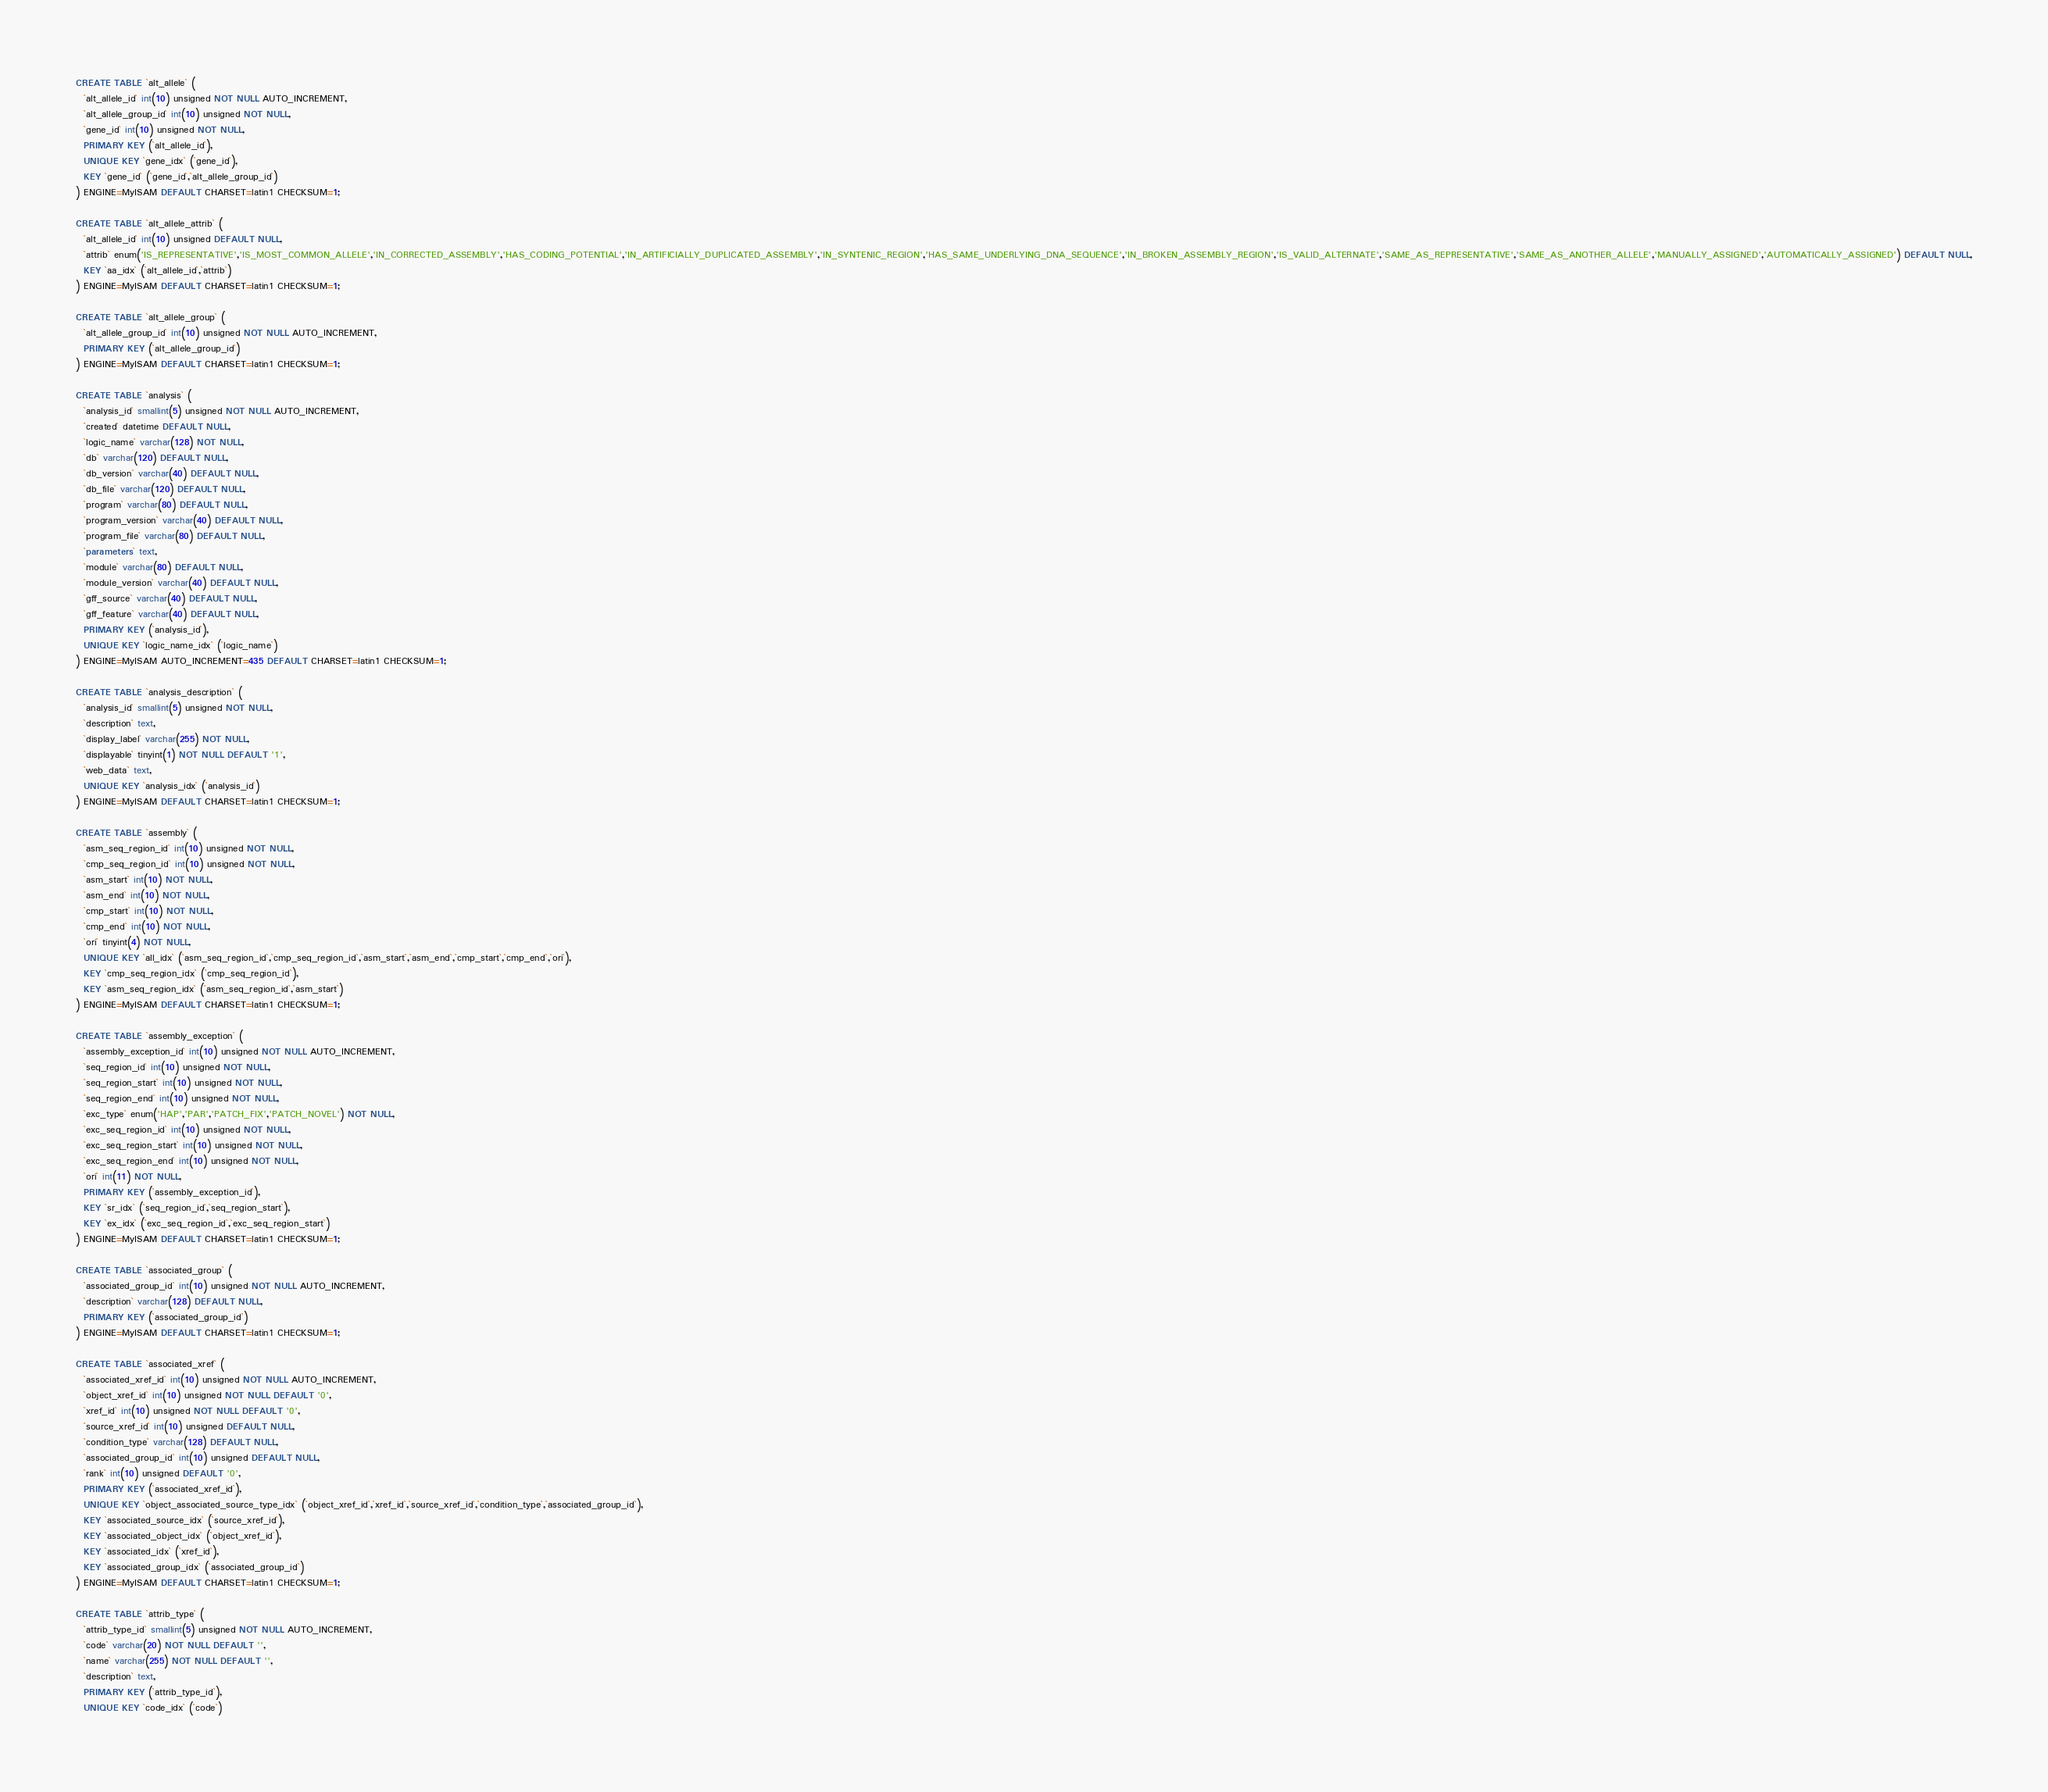<code> <loc_0><loc_0><loc_500><loc_500><_SQL_>CREATE TABLE `alt_allele` (
  `alt_allele_id` int(10) unsigned NOT NULL AUTO_INCREMENT,
  `alt_allele_group_id` int(10) unsigned NOT NULL,
  `gene_id` int(10) unsigned NOT NULL,
  PRIMARY KEY (`alt_allele_id`),
  UNIQUE KEY `gene_idx` (`gene_id`),
  KEY `gene_id` (`gene_id`,`alt_allele_group_id`)
) ENGINE=MyISAM DEFAULT CHARSET=latin1 CHECKSUM=1;

CREATE TABLE `alt_allele_attrib` (
  `alt_allele_id` int(10) unsigned DEFAULT NULL,
  `attrib` enum('IS_REPRESENTATIVE','IS_MOST_COMMON_ALLELE','IN_CORRECTED_ASSEMBLY','HAS_CODING_POTENTIAL','IN_ARTIFICIALLY_DUPLICATED_ASSEMBLY','IN_SYNTENIC_REGION','HAS_SAME_UNDERLYING_DNA_SEQUENCE','IN_BROKEN_ASSEMBLY_REGION','IS_VALID_ALTERNATE','SAME_AS_REPRESENTATIVE','SAME_AS_ANOTHER_ALLELE','MANUALLY_ASSIGNED','AUTOMATICALLY_ASSIGNED') DEFAULT NULL,
  KEY `aa_idx` (`alt_allele_id`,`attrib`)
) ENGINE=MyISAM DEFAULT CHARSET=latin1 CHECKSUM=1;

CREATE TABLE `alt_allele_group` (
  `alt_allele_group_id` int(10) unsigned NOT NULL AUTO_INCREMENT,
  PRIMARY KEY (`alt_allele_group_id`)
) ENGINE=MyISAM DEFAULT CHARSET=latin1 CHECKSUM=1;

CREATE TABLE `analysis` (
  `analysis_id` smallint(5) unsigned NOT NULL AUTO_INCREMENT,
  `created` datetime DEFAULT NULL,
  `logic_name` varchar(128) NOT NULL,
  `db` varchar(120) DEFAULT NULL,
  `db_version` varchar(40) DEFAULT NULL,
  `db_file` varchar(120) DEFAULT NULL,
  `program` varchar(80) DEFAULT NULL,
  `program_version` varchar(40) DEFAULT NULL,
  `program_file` varchar(80) DEFAULT NULL,
  `parameters` text,
  `module` varchar(80) DEFAULT NULL,
  `module_version` varchar(40) DEFAULT NULL,
  `gff_source` varchar(40) DEFAULT NULL,
  `gff_feature` varchar(40) DEFAULT NULL,
  PRIMARY KEY (`analysis_id`),
  UNIQUE KEY `logic_name_idx` (`logic_name`)
) ENGINE=MyISAM AUTO_INCREMENT=435 DEFAULT CHARSET=latin1 CHECKSUM=1;

CREATE TABLE `analysis_description` (
  `analysis_id` smallint(5) unsigned NOT NULL,
  `description` text,
  `display_label` varchar(255) NOT NULL,
  `displayable` tinyint(1) NOT NULL DEFAULT '1',
  `web_data` text,
  UNIQUE KEY `analysis_idx` (`analysis_id`)
) ENGINE=MyISAM DEFAULT CHARSET=latin1 CHECKSUM=1;

CREATE TABLE `assembly` (
  `asm_seq_region_id` int(10) unsigned NOT NULL,
  `cmp_seq_region_id` int(10) unsigned NOT NULL,
  `asm_start` int(10) NOT NULL,
  `asm_end` int(10) NOT NULL,
  `cmp_start` int(10) NOT NULL,
  `cmp_end` int(10) NOT NULL,
  `ori` tinyint(4) NOT NULL,
  UNIQUE KEY `all_idx` (`asm_seq_region_id`,`cmp_seq_region_id`,`asm_start`,`asm_end`,`cmp_start`,`cmp_end`,`ori`),
  KEY `cmp_seq_region_idx` (`cmp_seq_region_id`),
  KEY `asm_seq_region_idx` (`asm_seq_region_id`,`asm_start`)
) ENGINE=MyISAM DEFAULT CHARSET=latin1 CHECKSUM=1;

CREATE TABLE `assembly_exception` (
  `assembly_exception_id` int(10) unsigned NOT NULL AUTO_INCREMENT,
  `seq_region_id` int(10) unsigned NOT NULL,
  `seq_region_start` int(10) unsigned NOT NULL,
  `seq_region_end` int(10) unsigned NOT NULL,
  `exc_type` enum('HAP','PAR','PATCH_FIX','PATCH_NOVEL') NOT NULL,
  `exc_seq_region_id` int(10) unsigned NOT NULL,
  `exc_seq_region_start` int(10) unsigned NOT NULL,
  `exc_seq_region_end` int(10) unsigned NOT NULL,
  `ori` int(11) NOT NULL,
  PRIMARY KEY (`assembly_exception_id`),
  KEY `sr_idx` (`seq_region_id`,`seq_region_start`),
  KEY `ex_idx` (`exc_seq_region_id`,`exc_seq_region_start`)
) ENGINE=MyISAM DEFAULT CHARSET=latin1 CHECKSUM=1;

CREATE TABLE `associated_group` (
  `associated_group_id` int(10) unsigned NOT NULL AUTO_INCREMENT,
  `description` varchar(128) DEFAULT NULL,
  PRIMARY KEY (`associated_group_id`)
) ENGINE=MyISAM DEFAULT CHARSET=latin1 CHECKSUM=1;

CREATE TABLE `associated_xref` (
  `associated_xref_id` int(10) unsigned NOT NULL AUTO_INCREMENT,
  `object_xref_id` int(10) unsigned NOT NULL DEFAULT '0',
  `xref_id` int(10) unsigned NOT NULL DEFAULT '0',
  `source_xref_id` int(10) unsigned DEFAULT NULL,
  `condition_type` varchar(128) DEFAULT NULL,
  `associated_group_id` int(10) unsigned DEFAULT NULL,
  `rank` int(10) unsigned DEFAULT '0',
  PRIMARY KEY (`associated_xref_id`),
  UNIQUE KEY `object_associated_source_type_idx` (`object_xref_id`,`xref_id`,`source_xref_id`,`condition_type`,`associated_group_id`),
  KEY `associated_source_idx` (`source_xref_id`),
  KEY `associated_object_idx` (`object_xref_id`),
  KEY `associated_idx` (`xref_id`),
  KEY `associated_group_idx` (`associated_group_id`)
) ENGINE=MyISAM DEFAULT CHARSET=latin1 CHECKSUM=1;

CREATE TABLE `attrib_type` (
  `attrib_type_id` smallint(5) unsigned NOT NULL AUTO_INCREMENT,
  `code` varchar(20) NOT NULL DEFAULT '',
  `name` varchar(255) NOT NULL DEFAULT '',
  `description` text,
  PRIMARY KEY (`attrib_type_id`),
  UNIQUE KEY `code_idx` (`code`)</code> 